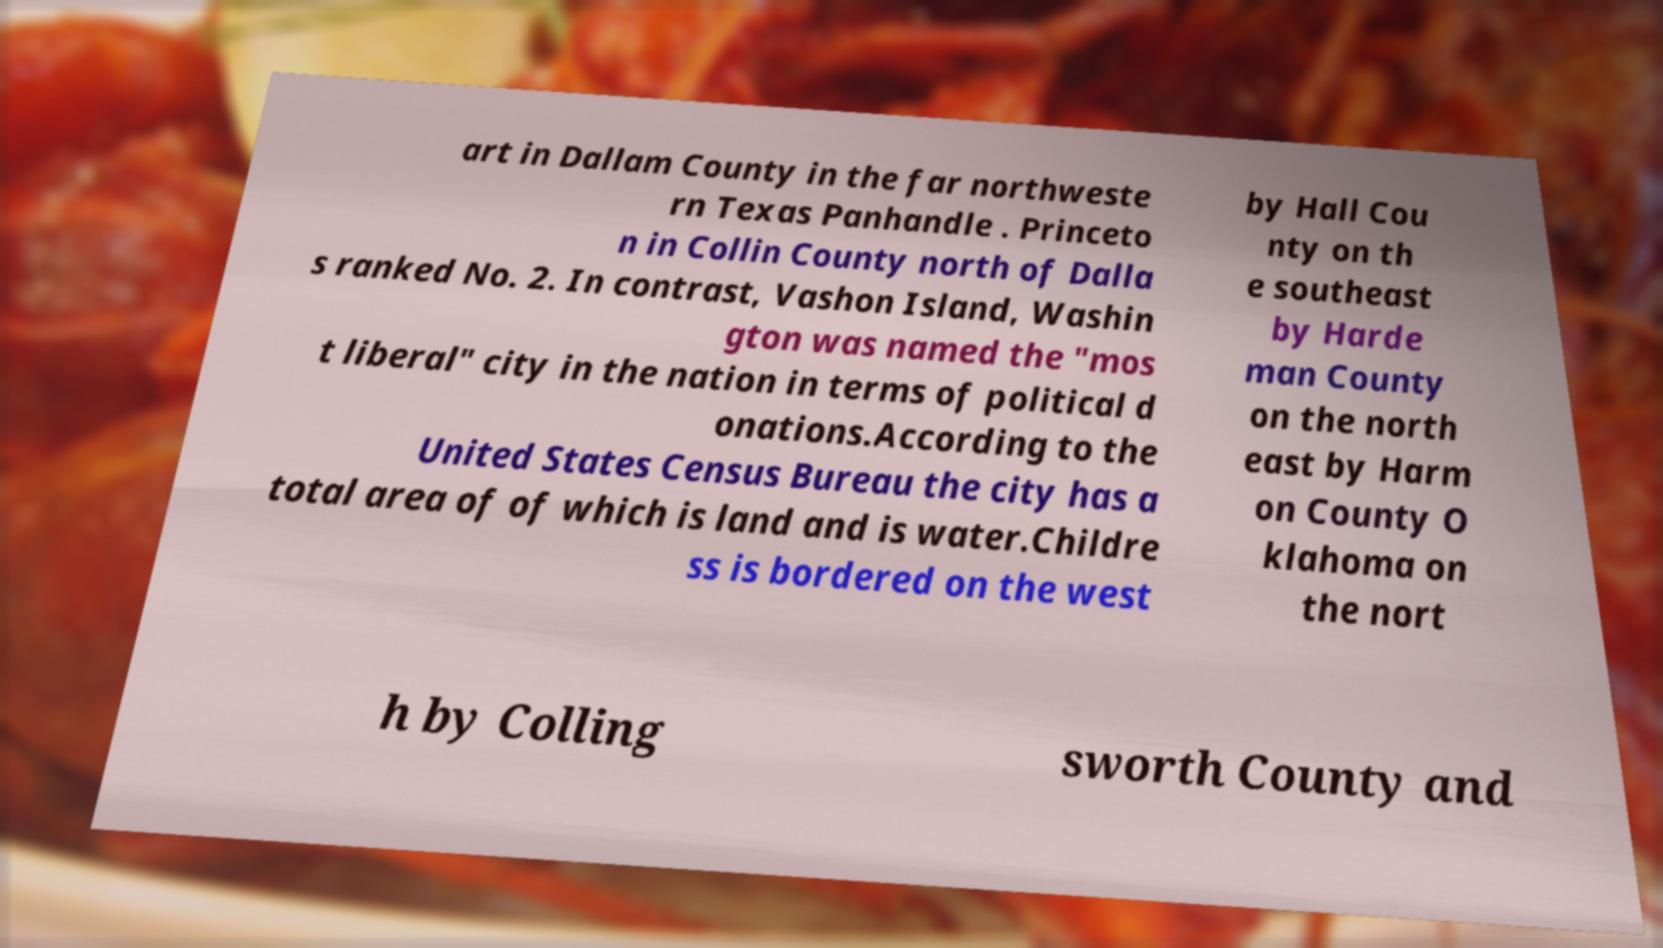For documentation purposes, I need the text within this image transcribed. Could you provide that? art in Dallam County in the far northweste rn Texas Panhandle . Princeto n in Collin County north of Dalla s ranked No. 2. In contrast, Vashon Island, Washin gton was named the "mos t liberal" city in the nation in terms of political d onations.According to the United States Census Bureau the city has a total area of of which is land and is water.Childre ss is bordered on the west by Hall Cou nty on th e southeast by Harde man County on the north east by Harm on County O klahoma on the nort h by Colling sworth County and 